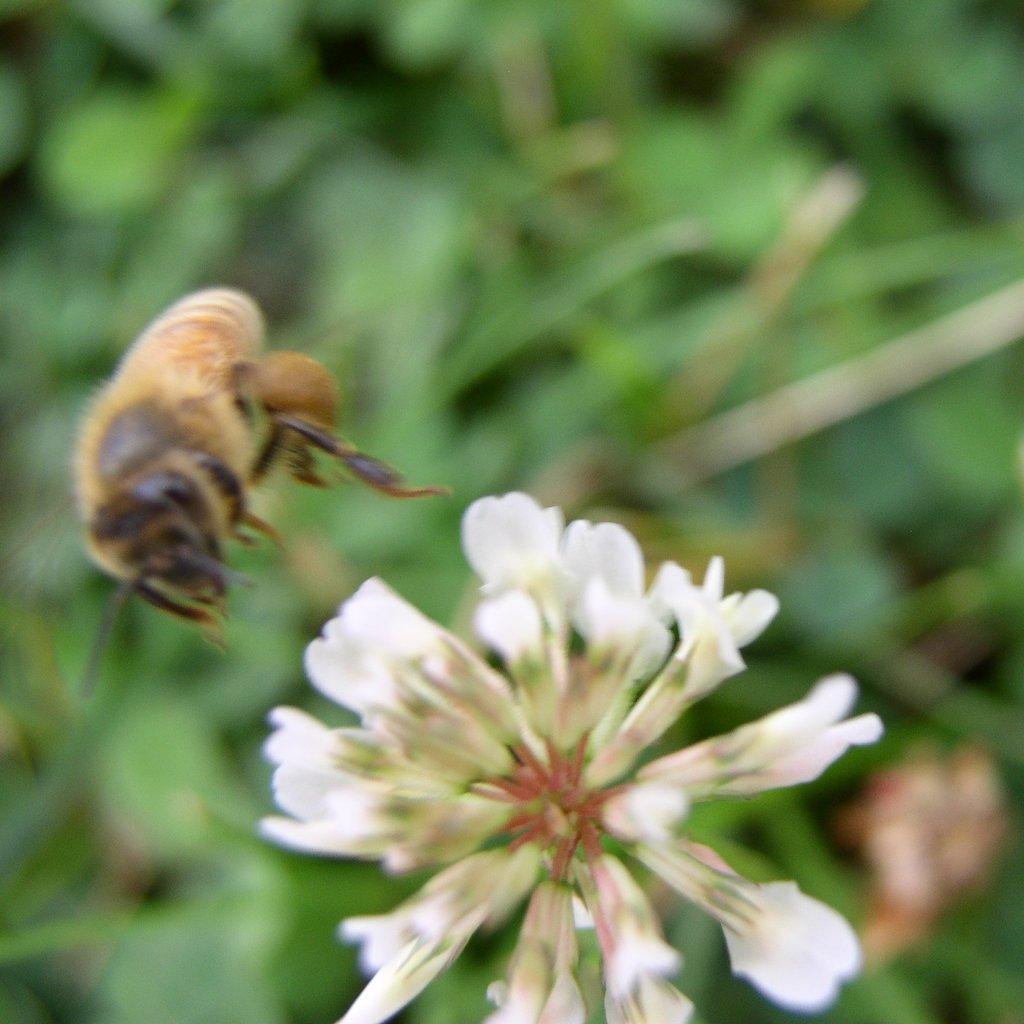Could you give a brief overview of what you see in this image? In the picture I can see an insect flying in the air. I can also see a white color flower. The background of the image is blurred. 